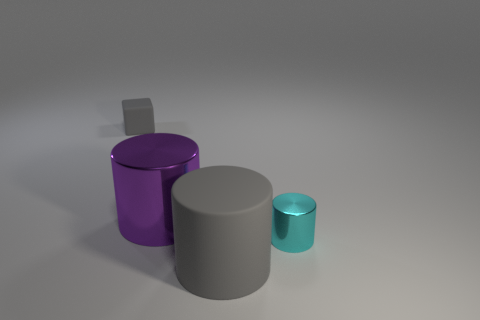How would you use these objects to explain the concepts of volume and surface area? The cylindrical objects in the image present an excellent opportunity to explore geometry. To find the volume of a cylinder, you would multiply the area of the base (which is a circle) by the height: Volume = π * radius^2 * height. For surface area, you'd calculate the areas of the two circular bases and the rectangular surface that forms the side when 'unrolled': Surface area = 2 * π * radius * (radius + height). By comparing the cylinders of different sizes, you can visually demonstrate how volume and surface area change proportionally. 